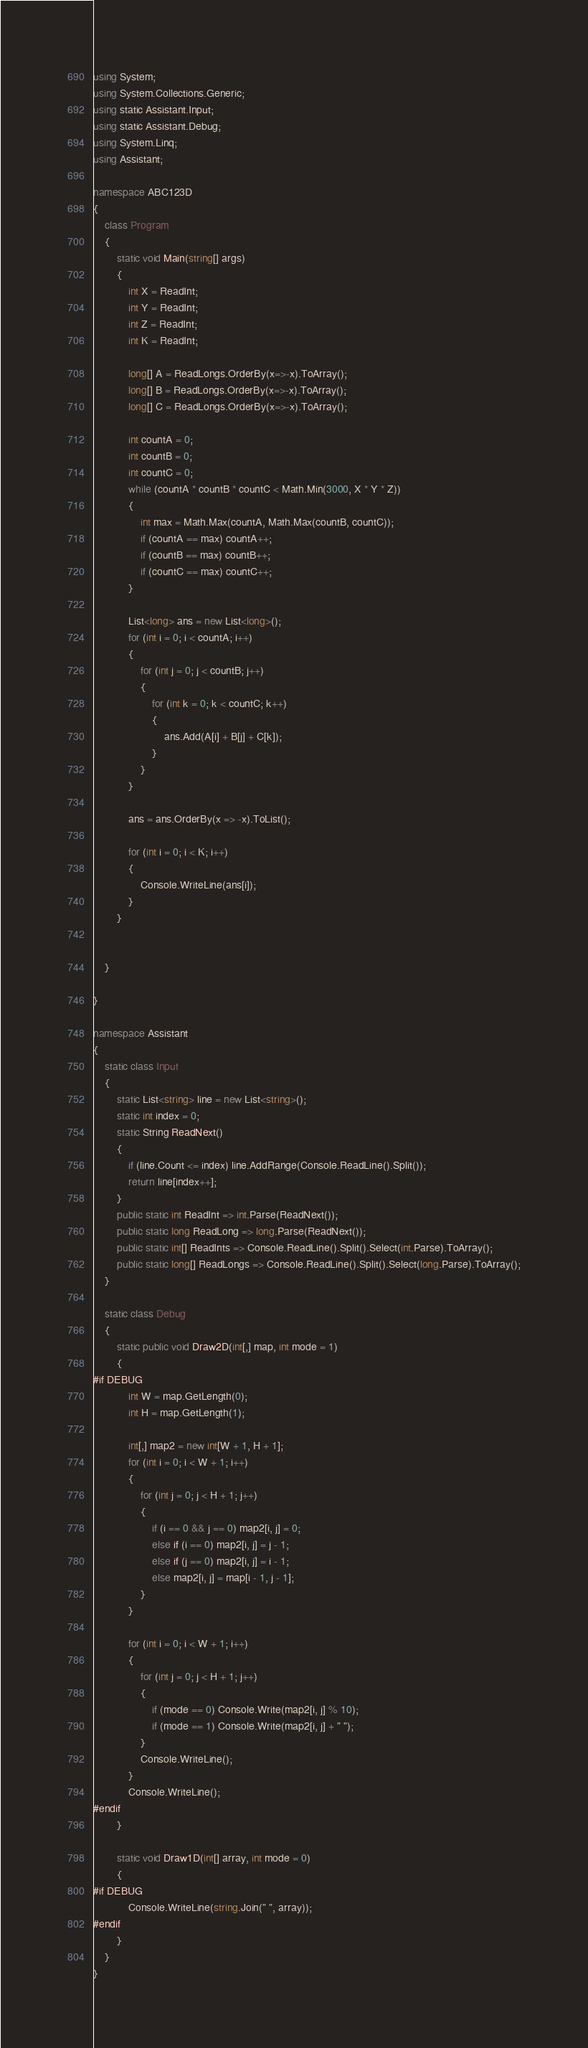Convert code to text. <code><loc_0><loc_0><loc_500><loc_500><_C#_>using System;
using System.Collections.Generic;
using static Assistant.Input;
using static Assistant.Debug;
using System.Linq;
using Assistant;

namespace ABC123D
{
    class Program
    {
        static void Main(string[] args)
        {
            int X = ReadInt;
            int Y = ReadInt;
            int Z = ReadInt;
            int K = ReadInt;

            long[] A = ReadLongs.OrderBy(x=>-x).ToArray();
            long[] B = ReadLongs.OrderBy(x=>-x).ToArray();
            long[] C = ReadLongs.OrderBy(x=>-x).ToArray();

            int countA = 0;
            int countB = 0;
            int countC = 0;
            while (countA * countB * countC < Math.Min(3000, X * Y * Z))
            {
                int max = Math.Max(countA, Math.Max(countB, countC));
                if (countA == max) countA++;
                if (countB == max) countB++;
                if (countC == max) countC++;
            }

            List<long> ans = new List<long>();
            for (int i = 0; i < countA; i++)
            {
                for (int j = 0; j < countB; j++)
                {
                    for (int k = 0; k < countC; k++)
                    {
                        ans.Add(A[i] + B[j] + C[k]);
                    }
                }
            }

            ans = ans.OrderBy(x => -x).ToList();

            for (int i = 0; i < K; i++)
            {
                Console.WriteLine(ans[i]);
            }
        }


    }

}

namespace Assistant
{
    static class Input
    {
        static List<string> line = new List<string>();
        static int index = 0;
        static String ReadNext()
        {
            if (line.Count <= index) line.AddRange(Console.ReadLine().Split());
            return line[index++];
        }
        public static int ReadInt => int.Parse(ReadNext());
        public static long ReadLong => long.Parse(ReadNext());
        public static int[] ReadInts => Console.ReadLine().Split().Select(int.Parse).ToArray();
        public static long[] ReadLongs => Console.ReadLine().Split().Select(long.Parse).ToArray();
    }

    static class Debug
    {
        static public void Draw2D(int[,] map, int mode = 1)
        {
#if DEBUG
            int W = map.GetLength(0);
            int H = map.GetLength(1);

            int[,] map2 = new int[W + 1, H + 1];
            for (int i = 0; i < W + 1; i++)
            {
                for (int j = 0; j < H + 1; j++)
                {
                    if (i == 0 && j == 0) map2[i, j] = 0;
                    else if (i == 0) map2[i, j] = j - 1;
                    else if (j == 0) map2[i, j] = i - 1;
                    else map2[i, j] = map[i - 1, j - 1];
                }
            }

            for (int i = 0; i < W + 1; i++)
            {
                for (int j = 0; j < H + 1; j++)
                {
                    if (mode == 0) Console.Write(map2[i, j] % 10);
                    if (mode == 1) Console.Write(map2[i, j] + " ");
                }
                Console.WriteLine();
            }
            Console.WriteLine();
#endif
        }

        static void Draw1D(int[] array, int mode = 0)
        {
#if DEBUG
            Console.WriteLine(string.Join(" ", array));
#endif
        }
    }
}
</code> 